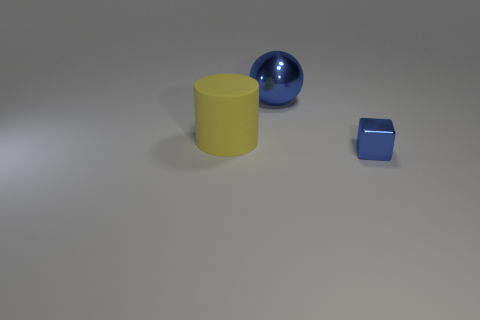Are there any green metallic cylinders that have the same size as the shiny block?
Your answer should be very brief. No. There is a blue metal thing that is behind the big yellow object; is there a rubber thing that is in front of it?
Offer a very short reply. Yes. What is the shape of the tiny object?
Your answer should be very brief. Cube. How many yellow cylinders have the same material as the tiny blue cube?
Give a very brief answer. 0. There is a small thing; is its color the same as the thing that is behind the big yellow thing?
Your answer should be compact. Yes. How many big matte balls are there?
Provide a succinct answer. 0. Are there any shiny objects that have the same color as the small cube?
Provide a short and direct response. Yes. What color is the object in front of the thing to the left of the blue object behind the shiny block?
Keep it short and to the point. Blue. Is the material of the big blue object the same as the big thing in front of the metal sphere?
Offer a terse response. No. What is the small object made of?
Ensure brevity in your answer.  Metal. 